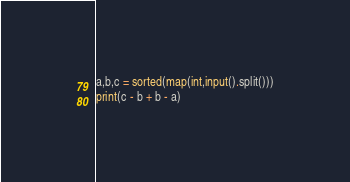<code> <loc_0><loc_0><loc_500><loc_500><_Python_>a,b,c = sorted(map(int,input().split()))
print(c - b + b - a)
</code> 